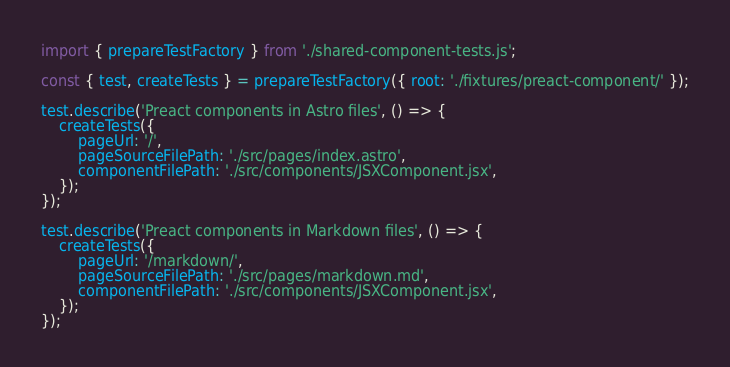Convert code to text. <code><loc_0><loc_0><loc_500><loc_500><_JavaScript_>import { prepareTestFactory } from './shared-component-tests.js';

const { test, createTests } = prepareTestFactory({ root: './fixtures/preact-component/' });

test.describe('Preact components in Astro files', () => {
	createTests({
		pageUrl: '/',
		pageSourceFilePath: './src/pages/index.astro',
		componentFilePath: './src/components/JSXComponent.jsx',
	});
});

test.describe('Preact components in Markdown files', () => {
	createTests({
		pageUrl: '/markdown/',
		pageSourceFilePath: './src/pages/markdown.md',
		componentFilePath: './src/components/JSXComponent.jsx',
	});
});
</code> 